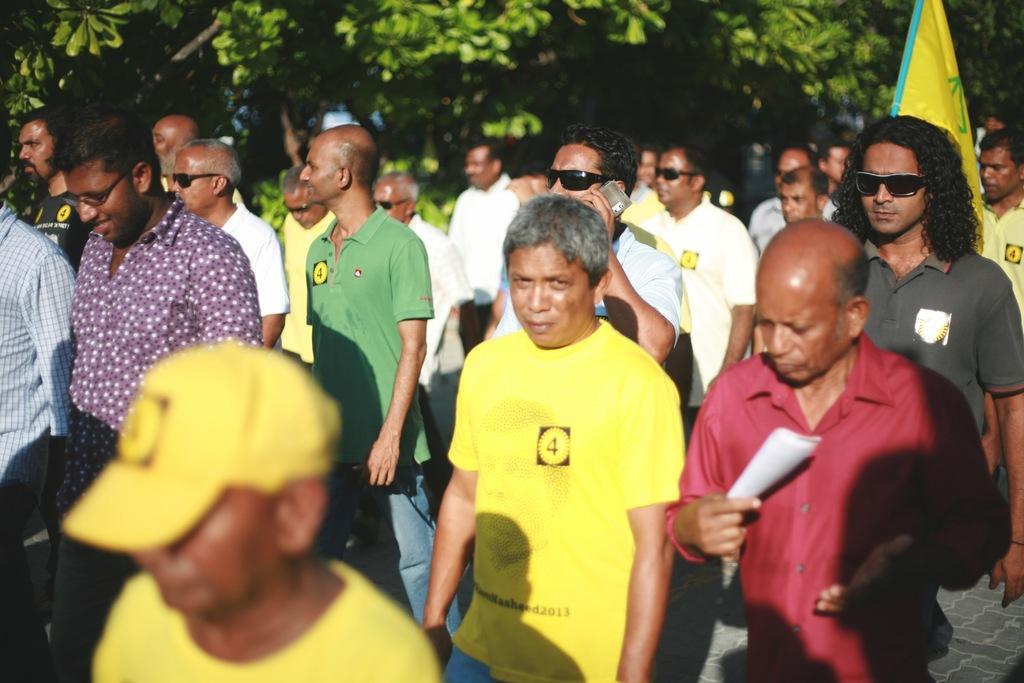Please provide a concise description of this image. In this image, there are a few people. Among them, we can see a person holding an object. We can see the ground and a flag. In the background, we can see some trees. 